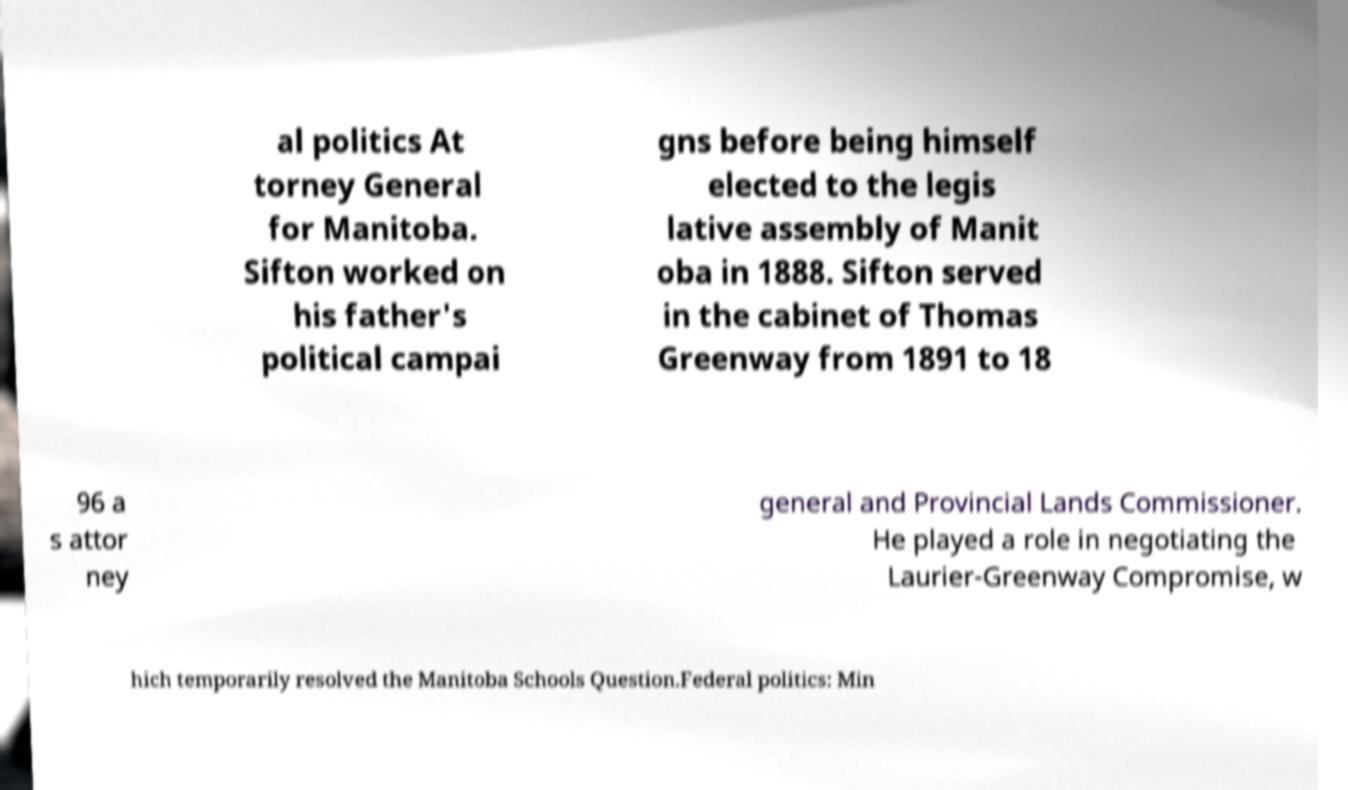Please identify and transcribe the text found in this image. al politics At torney General for Manitoba. Sifton worked on his father's political campai gns before being himself elected to the legis lative assembly of Manit oba in 1888. Sifton served in the cabinet of Thomas Greenway from 1891 to 18 96 a s attor ney general and Provincial Lands Commissioner. He played a role in negotiating the Laurier-Greenway Compromise, w hich temporarily resolved the Manitoba Schools Question.Federal politics: Min 